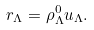<formula> <loc_0><loc_0><loc_500><loc_500>r _ { \Lambda } = \rho _ { \Lambda } ^ { 0 } u _ { \Lambda } .</formula> 